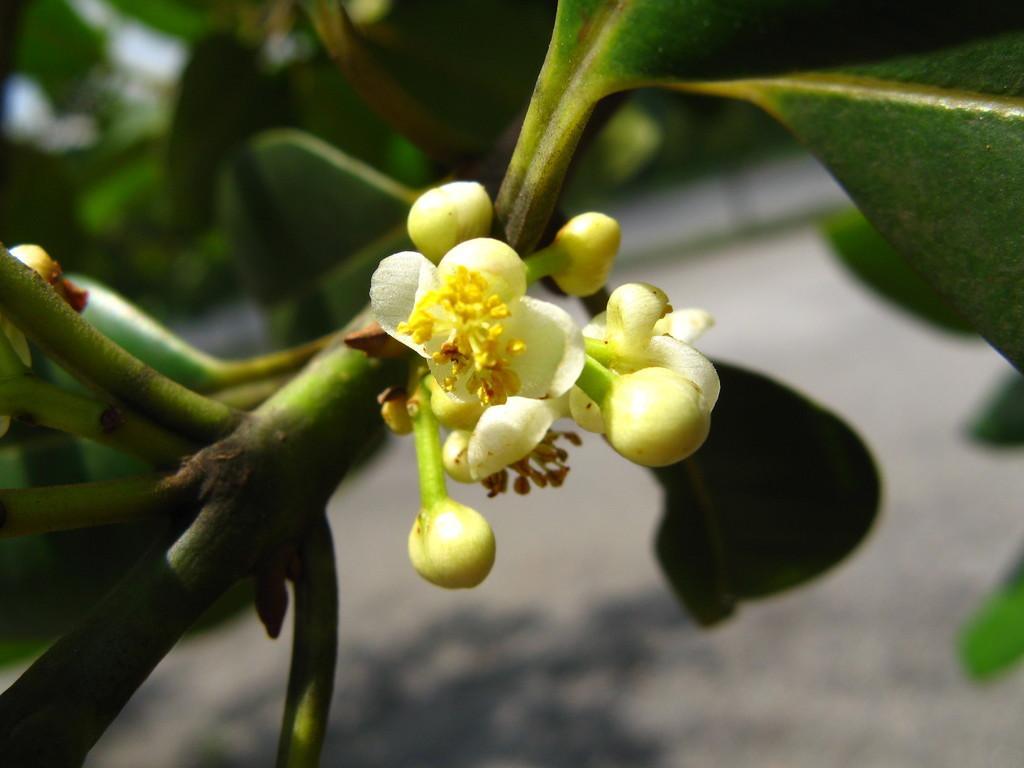What type of plant life is present in the image? There are flowers, flower buds, stems, and leaves in the image. Can you describe the different parts of the plants in the image? Yes, there are flowers, flower buds, stems, and leaves in the image. What is the background of the image like? The background of the image has a blurred view. How many pairs of shoes can be seen on the flowers in the image? There are no shoes present in the image; it features flowers, flower buds, stems, and leaves. Are there any boys visible in the image? There are no boys present in the image; it features flowers, flower buds, stems, and leaves. 